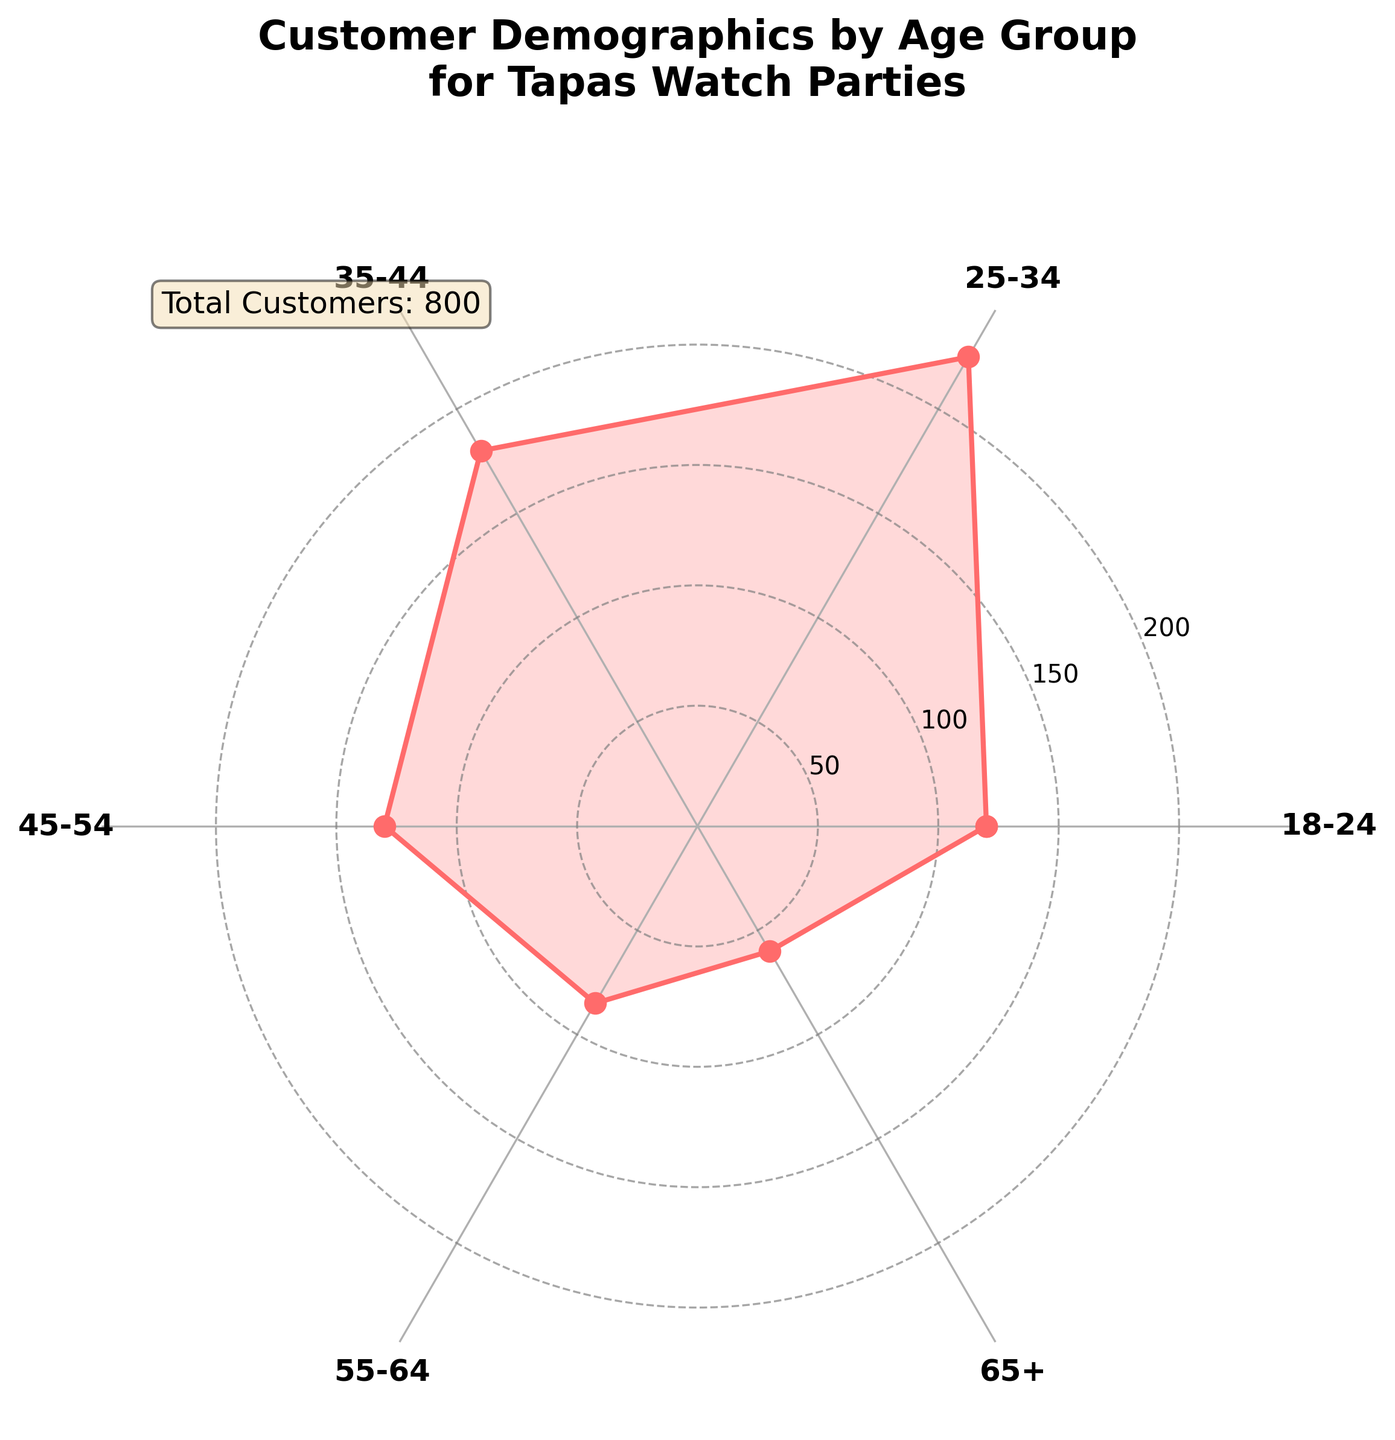What is the title of the chart? The title of the chart is displayed at the top, usually in a larger and bold font to make it easily distinguishable. The title in this case is "Customer Demographics by Age Group for Tapas Watch Parties".
Answer: Customer Demographics by Age Group for Tapas Watch Parties Which age group has the highest number of customers? Observing the lengths of the radial bar segments, the age group with the largest radius represents the highest number of customers. The segment labeled "25-34" is the longest.
Answer: 25-34 What is the smallest age group represented in the chart? By comparing the lengths of all the radial segments, the shortest segment represents the age group with the smallest number of customers, which corresponds to the "65+" group.
Answer: 65+ What is the total number of customers represented in the chart? The total number of customers is noted in a text box within the plot, typically included in the legend-like section. The text box information reads 'Total Customers: 800'.
Answer: 800 Which age group has more customers, 45-54 or 55-64? Compare the radial lengths of these two age groups. The segment for 45-54 is longer than for 55-64, indicating more customers.
Answer: 45-54 Is there any age group with exactly 130 customers? Check the numerical labels next to each segment. The label 130 corresponds to the 45-54 age group.
Answer: Yes, 45-54 How does the number of customers in the 35-44 age group compare to those in the 65+ age group? Compare the radial length of the 35-44 segment with the 65+ segment. The 35-44 segment is significantly longer, indicating more customers in this group.
Answer: 35-44 > 65+ 